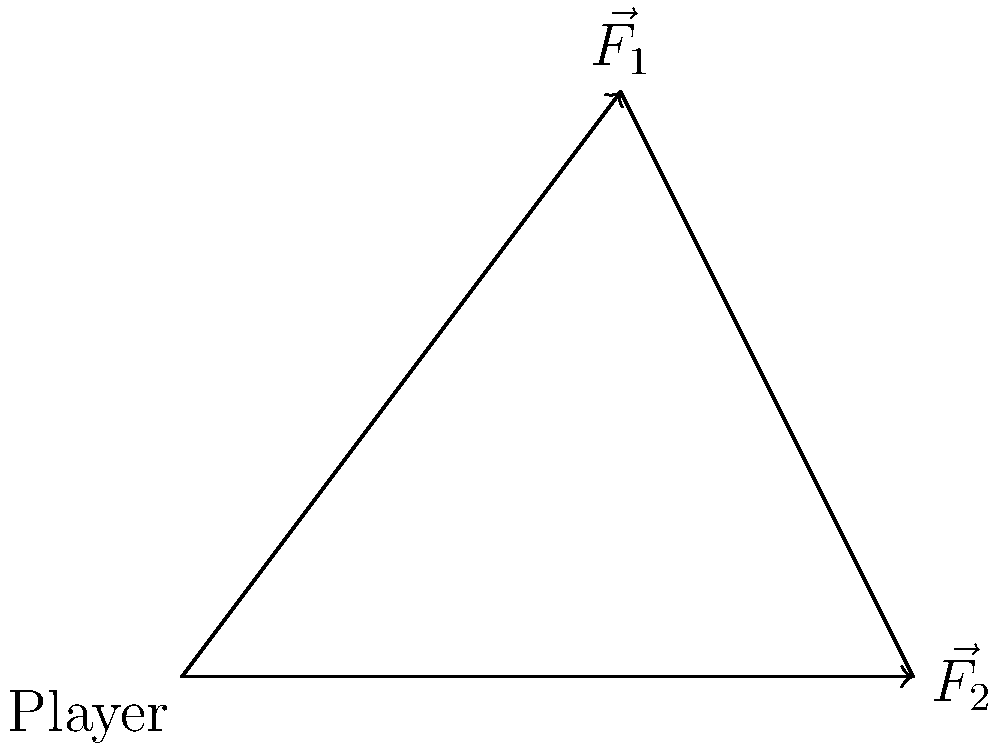During a local match, you observe a tackle where two players exert forces on another player. The diagram shows the force vectors acting on the tackled player. $\vec{F_1}$ has a magnitude of 3 N and $\vec{F_2}$ has a magnitude of 5 N. What is the magnitude of the resultant force acting on the player? To find the magnitude of the resultant force, we'll use the law of cosines. Here's how:

1) First, we need to find the angle between the two force vectors. From the diagram, we can see that this angle is $90^\circ + 53.1^\circ = 143.1^\circ$.

2) The law of cosines states that for a triangle with sides a, b, and c, and an angle C opposite side c:

   $c^2 = a^2 + b^2 - 2ab \cos(C)$

3) In our case:
   a = 3 N (magnitude of $\vec{F_1}$)
   b = 5 N (magnitude of $\vec{F_2}$)
   C = 143.1° (angle between the vectors)

4) Let's substitute these values into the formula:

   $R^2 = 3^2 + 5^2 - 2(3)(5) \cos(143.1^\circ)$

5) Simplify:
   $R^2 = 9 + 25 - 30 \cos(143.1^\circ)$
   $R^2 = 34 + 24.12$ (since $\cos(143.1^\circ) \approx -0.804$)
   $R^2 = 58.12$

6) Take the square root of both sides:
   $R = \sqrt{58.12} \approx 7.62$ N

Therefore, the magnitude of the resultant force is approximately 7.62 N.
Answer: 7.62 N 